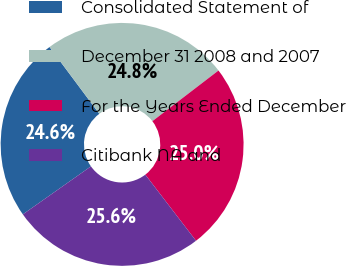Convert chart. <chart><loc_0><loc_0><loc_500><loc_500><pie_chart><fcel>Consolidated Statement of<fcel>December 31 2008 and 2007<fcel>For the Years Ended December<fcel>Citibank NA and<nl><fcel>24.58%<fcel>24.79%<fcel>25.0%<fcel>25.64%<nl></chart> 